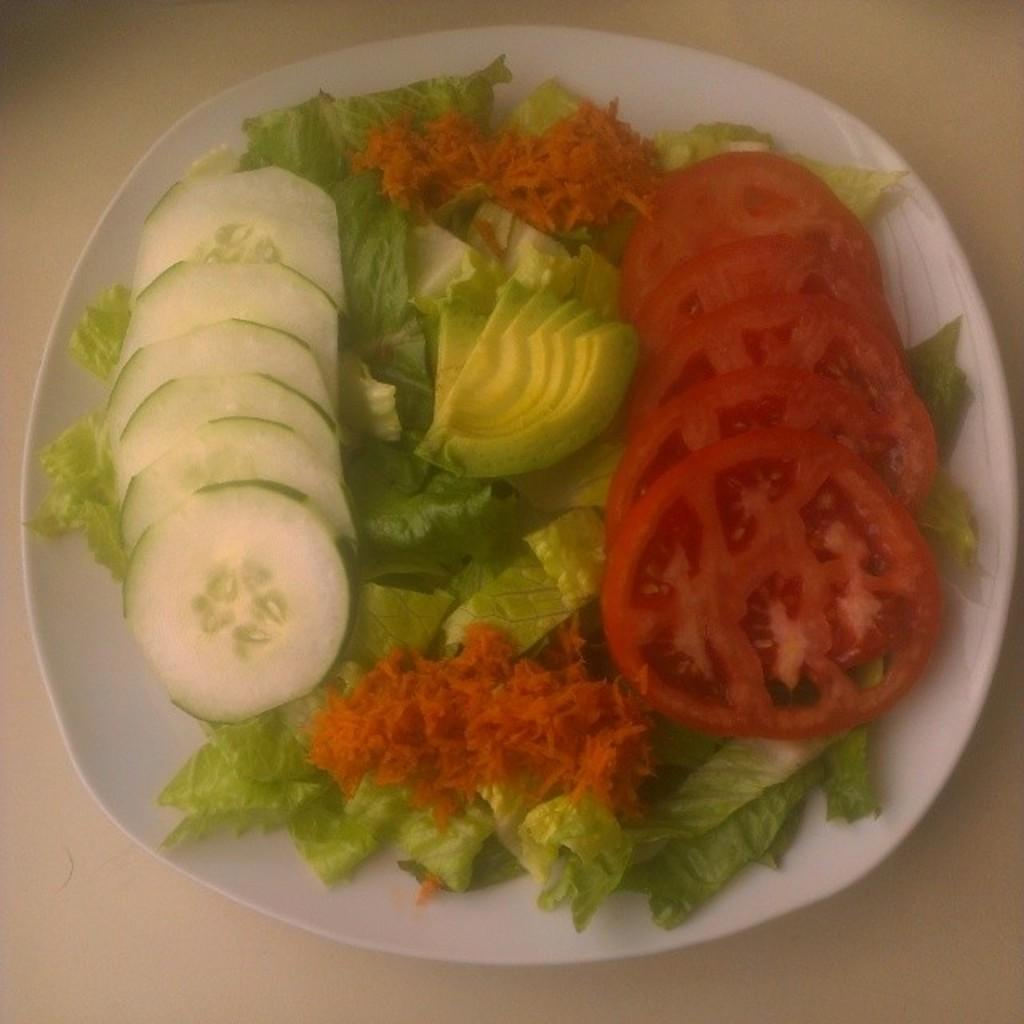What is on the plate in the foreground of the image? The plate contains cucumber, tomato, kiwi, and leafy vegetables. Where is the plate located in the image? The plate is on a table. In what type of setting is the plate located? The image is taken in a room. What type of steel is used to construct the governor's residence in the image? There is no governor's residence or steel construction present in the image. 